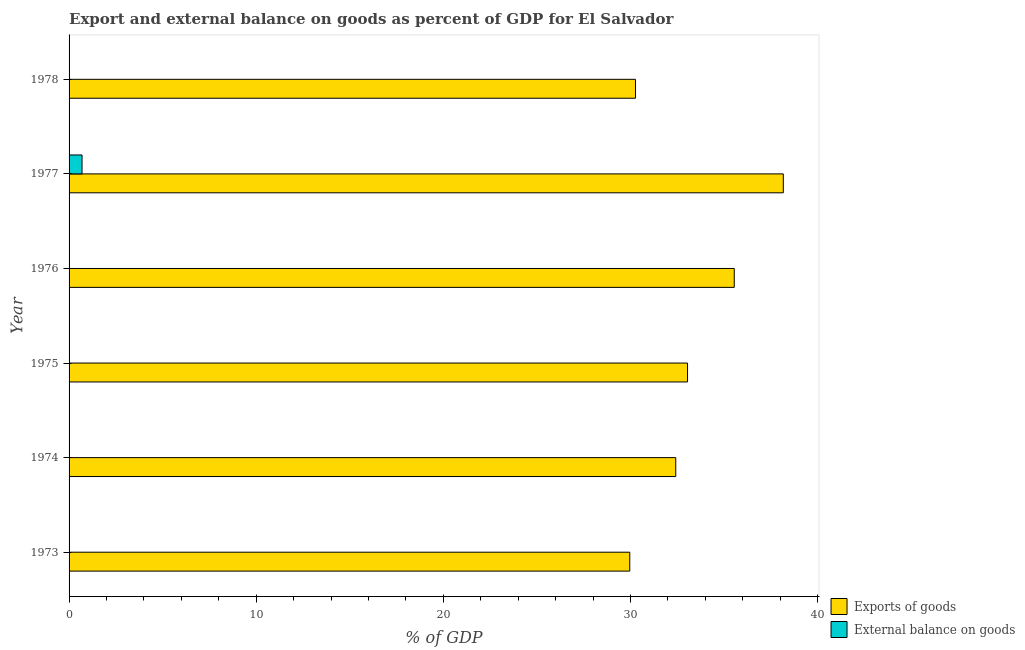Are the number of bars per tick equal to the number of legend labels?
Give a very brief answer. No. Are the number of bars on each tick of the Y-axis equal?
Keep it short and to the point. No. What is the label of the 4th group of bars from the top?
Your response must be concise. 1975. Across all years, what is the maximum export of goods as percentage of gdp?
Ensure brevity in your answer.  38.17. Across all years, what is the minimum export of goods as percentage of gdp?
Offer a terse response. 29.96. In which year was the export of goods as percentage of gdp maximum?
Your answer should be compact. 1977. What is the total external balance on goods as percentage of gdp in the graph?
Keep it short and to the point. 0.69. What is the difference between the export of goods as percentage of gdp in 1977 and that in 1978?
Provide a short and direct response. 7.9. What is the difference between the external balance on goods as percentage of gdp in 1973 and the export of goods as percentage of gdp in 1977?
Provide a short and direct response. -38.17. What is the average external balance on goods as percentage of gdp per year?
Your response must be concise. 0.12. In the year 1977, what is the difference between the export of goods as percentage of gdp and external balance on goods as percentage of gdp?
Provide a short and direct response. 37.47. What is the ratio of the export of goods as percentage of gdp in 1977 to that in 1978?
Provide a succinct answer. 1.26. Is the export of goods as percentage of gdp in 1974 less than that in 1976?
Provide a succinct answer. Yes. What is the difference between the highest and the second highest export of goods as percentage of gdp?
Ensure brevity in your answer.  2.62. What is the difference between the highest and the lowest external balance on goods as percentage of gdp?
Provide a short and direct response. 0.69. How many bars are there?
Ensure brevity in your answer.  7. Are all the bars in the graph horizontal?
Provide a short and direct response. Yes. How many years are there in the graph?
Keep it short and to the point. 6. What is the difference between two consecutive major ticks on the X-axis?
Make the answer very short. 10. Are the values on the major ticks of X-axis written in scientific E-notation?
Your answer should be compact. No. What is the title of the graph?
Give a very brief answer. Export and external balance on goods as percent of GDP for El Salvador. What is the label or title of the X-axis?
Provide a short and direct response. % of GDP. What is the label or title of the Y-axis?
Give a very brief answer. Year. What is the % of GDP in Exports of goods in 1973?
Your answer should be very brief. 29.96. What is the % of GDP in External balance on goods in 1973?
Ensure brevity in your answer.  0. What is the % of GDP in Exports of goods in 1974?
Provide a short and direct response. 32.42. What is the % of GDP in External balance on goods in 1974?
Give a very brief answer. 0. What is the % of GDP of Exports of goods in 1975?
Keep it short and to the point. 33.05. What is the % of GDP of Exports of goods in 1976?
Provide a succinct answer. 35.54. What is the % of GDP of Exports of goods in 1977?
Ensure brevity in your answer.  38.17. What is the % of GDP of External balance on goods in 1977?
Offer a very short reply. 0.69. What is the % of GDP in Exports of goods in 1978?
Offer a very short reply. 30.27. Across all years, what is the maximum % of GDP in Exports of goods?
Make the answer very short. 38.17. Across all years, what is the maximum % of GDP in External balance on goods?
Give a very brief answer. 0.69. Across all years, what is the minimum % of GDP in Exports of goods?
Provide a short and direct response. 29.96. Across all years, what is the minimum % of GDP in External balance on goods?
Provide a succinct answer. 0. What is the total % of GDP in Exports of goods in the graph?
Give a very brief answer. 199.4. What is the total % of GDP in External balance on goods in the graph?
Your response must be concise. 0.69. What is the difference between the % of GDP of Exports of goods in 1973 and that in 1974?
Offer a very short reply. -2.46. What is the difference between the % of GDP of Exports of goods in 1973 and that in 1975?
Make the answer very short. -3.09. What is the difference between the % of GDP of Exports of goods in 1973 and that in 1976?
Provide a succinct answer. -5.58. What is the difference between the % of GDP in Exports of goods in 1973 and that in 1977?
Offer a terse response. -8.21. What is the difference between the % of GDP in Exports of goods in 1973 and that in 1978?
Provide a succinct answer. -0.31. What is the difference between the % of GDP of Exports of goods in 1974 and that in 1975?
Provide a succinct answer. -0.63. What is the difference between the % of GDP of Exports of goods in 1974 and that in 1976?
Ensure brevity in your answer.  -3.13. What is the difference between the % of GDP in Exports of goods in 1974 and that in 1977?
Give a very brief answer. -5.75. What is the difference between the % of GDP in Exports of goods in 1974 and that in 1978?
Your response must be concise. 2.15. What is the difference between the % of GDP of Exports of goods in 1975 and that in 1976?
Provide a short and direct response. -2.5. What is the difference between the % of GDP of Exports of goods in 1975 and that in 1977?
Your response must be concise. -5.12. What is the difference between the % of GDP in Exports of goods in 1975 and that in 1978?
Your response must be concise. 2.78. What is the difference between the % of GDP of Exports of goods in 1976 and that in 1977?
Provide a short and direct response. -2.62. What is the difference between the % of GDP of Exports of goods in 1976 and that in 1978?
Your answer should be compact. 5.28. What is the difference between the % of GDP in Exports of goods in 1977 and that in 1978?
Ensure brevity in your answer.  7.9. What is the difference between the % of GDP of Exports of goods in 1973 and the % of GDP of External balance on goods in 1977?
Keep it short and to the point. 29.27. What is the difference between the % of GDP of Exports of goods in 1974 and the % of GDP of External balance on goods in 1977?
Your response must be concise. 31.73. What is the difference between the % of GDP in Exports of goods in 1975 and the % of GDP in External balance on goods in 1977?
Give a very brief answer. 32.35. What is the difference between the % of GDP in Exports of goods in 1976 and the % of GDP in External balance on goods in 1977?
Your answer should be compact. 34.85. What is the average % of GDP of Exports of goods per year?
Offer a terse response. 33.23. What is the average % of GDP in External balance on goods per year?
Provide a short and direct response. 0.12. In the year 1977, what is the difference between the % of GDP of Exports of goods and % of GDP of External balance on goods?
Provide a succinct answer. 37.47. What is the ratio of the % of GDP of Exports of goods in 1973 to that in 1974?
Make the answer very short. 0.92. What is the ratio of the % of GDP of Exports of goods in 1973 to that in 1975?
Your answer should be very brief. 0.91. What is the ratio of the % of GDP in Exports of goods in 1973 to that in 1976?
Keep it short and to the point. 0.84. What is the ratio of the % of GDP in Exports of goods in 1973 to that in 1977?
Provide a short and direct response. 0.79. What is the ratio of the % of GDP of Exports of goods in 1973 to that in 1978?
Keep it short and to the point. 0.99. What is the ratio of the % of GDP of Exports of goods in 1974 to that in 1976?
Your response must be concise. 0.91. What is the ratio of the % of GDP in Exports of goods in 1974 to that in 1977?
Provide a short and direct response. 0.85. What is the ratio of the % of GDP of Exports of goods in 1974 to that in 1978?
Offer a very short reply. 1.07. What is the ratio of the % of GDP of Exports of goods in 1975 to that in 1976?
Offer a terse response. 0.93. What is the ratio of the % of GDP of Exports of goods in 1975 to that in 1977?
Make the answer very short. 0.87. What is the ratio of the % of GDP in Exports of goods in 1975 to that in 1978?
Offer a terse response. 1.09. What is the ratio of the % of GDP in Exports of goods in 1976 to that in 1977?
Offer a very short reply. 0.93. What is the ratio of the % of GDP of Exports of goods in 1976 to that in 1978?
Make the answer very short. 1.17. What is the ratio of the % of GDP of Exports of goods in 1977 to that in 1978?
Give a very brief answer. 1.26. What is the difference between the highest and the second highest % of GDP of Exports of goods?
Provide a short and direct response. 2.62. What is the difference between the highest and the lowest % of GDP of Exports of goods?
Offer a very short reply. 8.21. What is the difference between the highest and the lowest % of GDP of External balance on goods?
Provide a short and direct response. 0.69. 